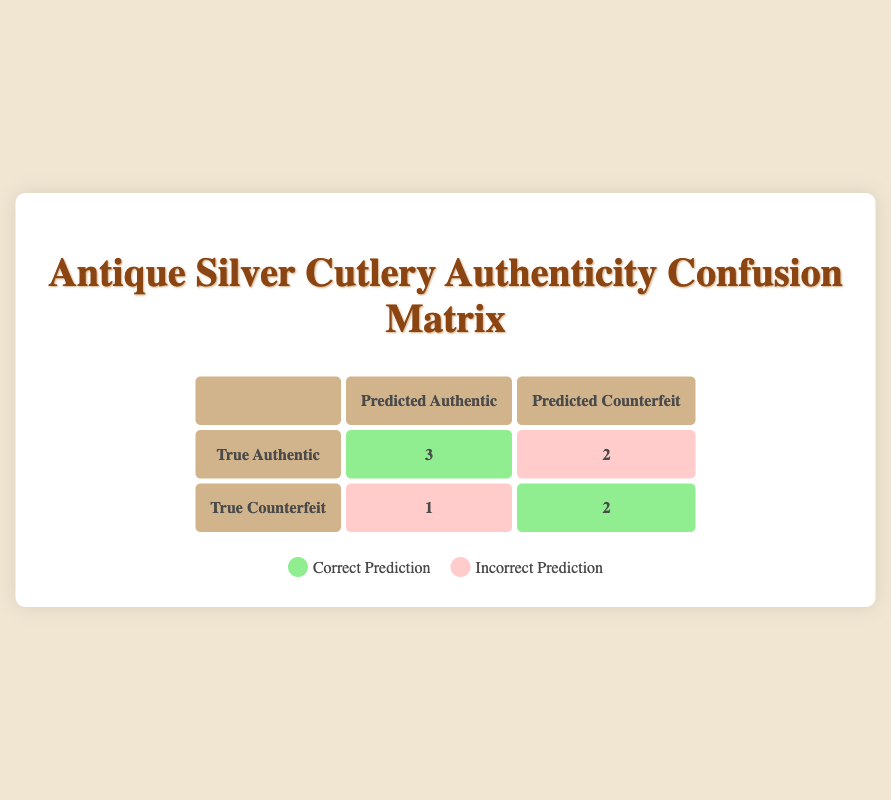What is the total number of authentic items predicted as counterfeit? From the confusion matrix, we see that the true label for the William Rogers Silver Fork is authentic but it was predicted as counterfeit, equating to 1 authentic item predicted as counterfeit. Additionally, the H. W. Hargreaves Silver Dessert Fork is also authentic but was incorrectly classified as counterfeit, giving us a total of 2 authentic items predicted as counterfeit.
Answer: 2 What is the number of counterfeit items accurately identified? Looking at the confusion matrix, we find that the true negatives represent counterfeit items predicted as counterfeit. This number is 2 according to the table.
Answer: 2 Is the Tiffany & Co. Silver Knife considered an authentic item in the predictions? The true label for the Tiffany & Co. Silver Knife is marked as authentic and it is also predicted as authentic. Therefore, it is considered an authentic item in the predictions.
Answer: Yes How many total items were analyzed in this authenticity verification? We can find the total number of analyzed items by counting all entries in the confusion matrix. There are 8 items listed in total, as shown in the validation outcomes.
Answer: 8 What is the difference between the number of true positives and false positives? True positives are the cases where authentic items were predicted as authentic, which is 3. False positives are cases where counterfeit items were predicted as authentic, which is 1. The difference is 3 - 1 = 2.
Answer: 2 What percentage of true authentic items were predicted correctly? Out of 5 true authentic items (3 true positives and 2 false negatives), 3 were predicted correctly. To get the percentage, we calculate (3/5) * 100, which equals 60%.
Answer: 60% How many total items were misclassified as counterfeit? There are 2 items that were actually authentic but were predicted as counterfeit (William Rogers Silver Fork and H. W. Hargreaves Silver Dessert Fork), and the Reed & Barton Silver Teaspoon which was counterfeit but predicted as authentic. Therefore, a total of 3 items were misclassified as counterfeit.
Answer: 3 Is the prediction accuracy for identifying authentic items better than for counterfeit items? To establish this, we examine the metrics: True Positive Rate (for authentic) is 60% (3 out of 5) while the True Negative Rate (for counterfeit) is 100% (2 out of 2). Thus, prediction accuracy for counterfeit items is better than for authentic items.
Answer: No 